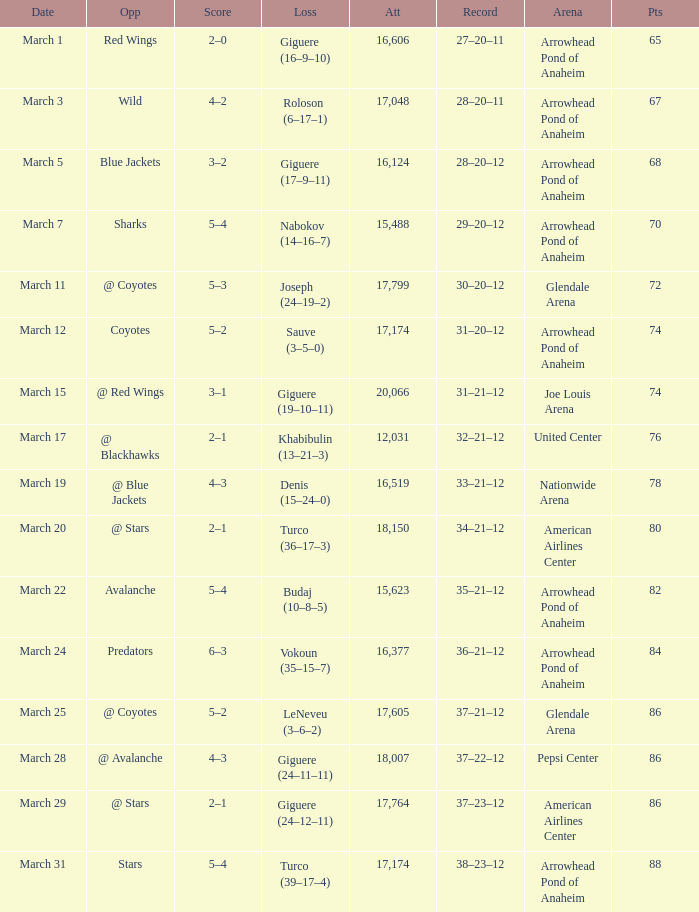On march 19, what was the outcome of the game? 4–3. 